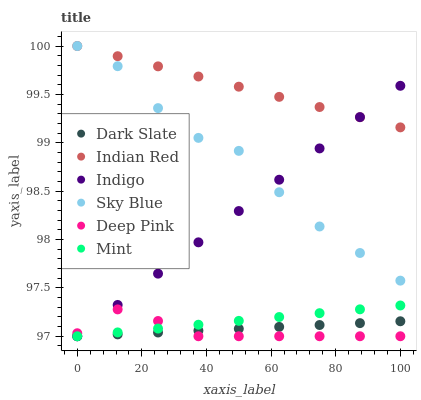Does Deep Pink have the minimum area under the curve?
Answer yes or no. Yes. Does Indian Red have the maximum area under the curve?
Answer yes or no. Yes. Does Indigo have the minimum area under the curve?
Answer yes or no. No. Does Indigo have the maximum area under the curve?
Answer yes or no. No. Is Indian Red the smoothest?
Answer yes or no. Yes. Is Sky Blue the roughest?
Answer yes or no. Yes. Is Indigo the smoothest?
Answer yes or no. No. Is Indigo the roughest?
Answer yes or no. No. Does Deep Pink have the lowest value?
Answer yes or no. Yes. Does Indian Red have the lowest value?
Answer yes or no. No. Does Sky Blue have the highest value?
Answer yes or no. Yes. Does Indigo have the highest value?
Answer yes or no. No. Is Mint less than Sky Blue?
Answer yes or no. Yes. Is Indian Red greater than Deep Pink?
Answer yes or no. Yes. Does Indian Red intersect Indigo?
Answer yes or no. Yes. Is Indian Red less than Indigo?
Answer yes or no. No. Is Indian Red greater than Indigo?
Answer yes or no. No. Does Mint intersect Sky Blue?
Answer yes or no. No. 